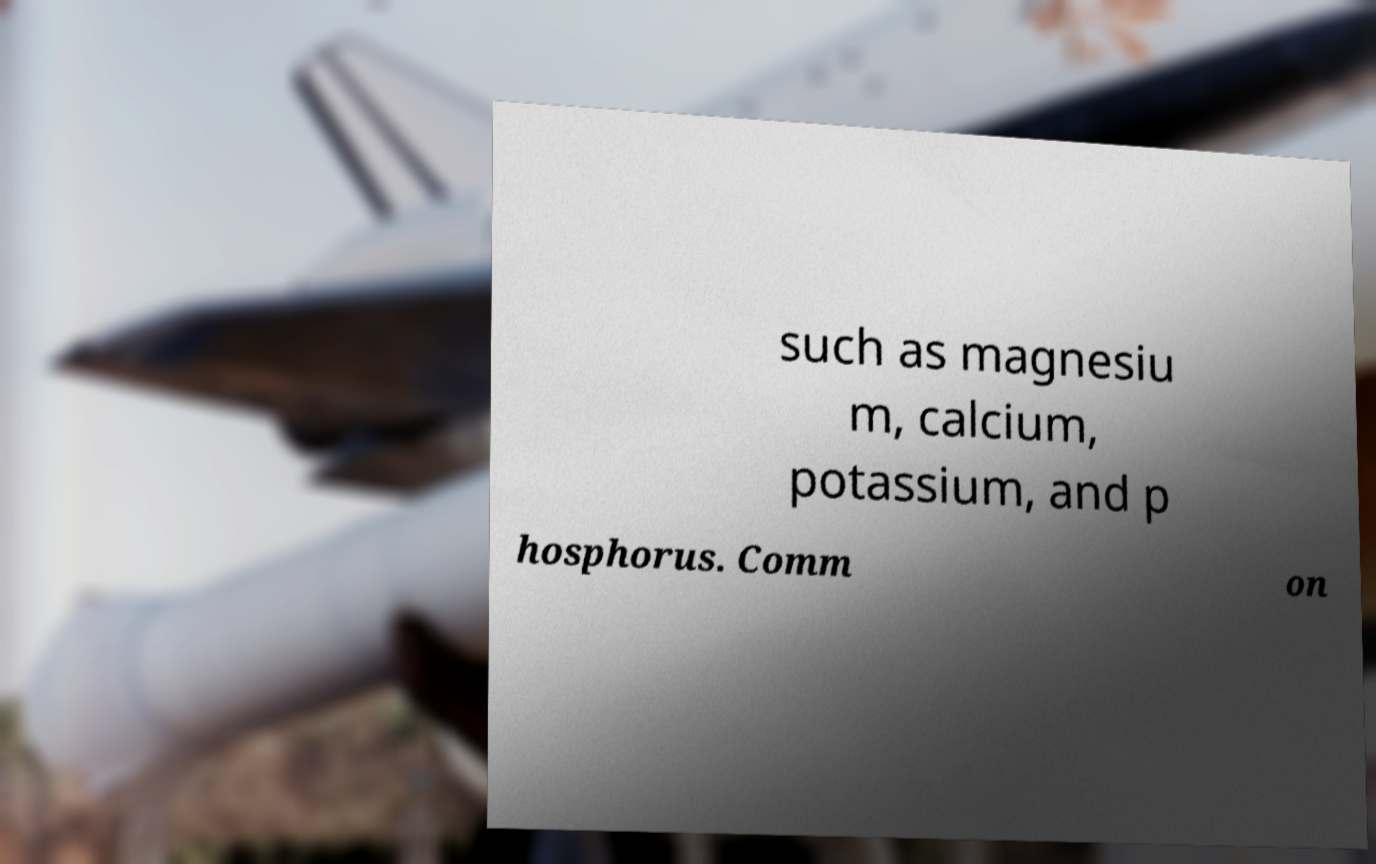What messages or text are displayed in this image? I need them in a readable, typed format. such as magnesiu m, calcium, potassium, and p hosphorus. Comm on 